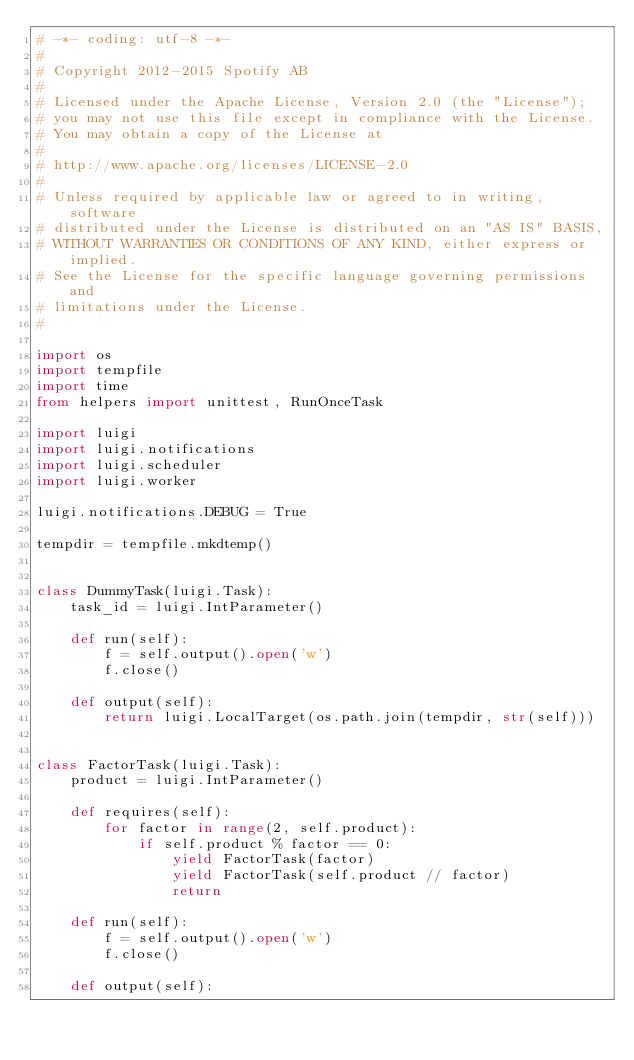Convert code to text. <code><loc_0><loc_0><loc_500><loc_500><_Python_># -*- coding: utf-8 -*-
#
# Copyright 2012-2015 Spotify AB
#
# Licensed under the Apache License, Version 2.0 (the "License");
# you may not use this file except in compliance with the License.
# You may obtain a copy of the License at
#
# http://www.apache.org/licenses/LICENSE-2.0
#
# Unless required by applicable law or agreed to in writing, software
# distributed under the License is distributed on an "AS IS" BASIS,
# WITHOUT WARRANTIES OR CONDITIONS OF ANY KIND, either express or implied.
# See the License for the specific language governing permissions and
# limitations under the License.
#

import os
import tempfile
import time
from helpers import unittest, RunOnceTask

import luigi
import luigi.notifications
import luigi.scheduler
import luigi.worker

luigi.notifications.DEBUG = True

tempdir = tempfile.mkdtemp()


class DummyTask(luigi.Task):
    task_id = luigi.IntParameter()

    def run(self):
        f = self.output().open('w')
        f.close()

    def output(self):
        return luigi.LocalTarget(os.path.join(tempdir, str(self)))


class FactorTask(luigi.Task):
    product = luigi.IntParameter()

    def requires(self):
        for factor in range(2, self.product):
            if self.product % factor == 0:
                yield FactorTask(factor)
                yield FactorTask(self.product // factor)
                return

    def run(self):
        f = self.output().open('w')
        f.close()

    def output(self):</code> 